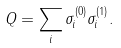<formula> <loc_0><loc_0><loc_500><loc_500>Q = \sum _ { i } \sigma ^ { ( 0 ) } _ { i } \sigma ^ { ( 1 ) } _ { i } .</formula> 